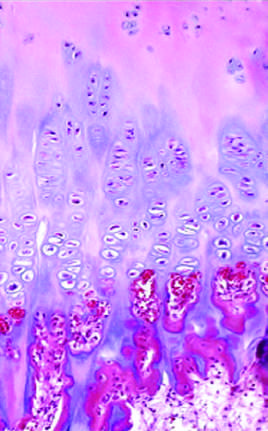what is absent?
Answer the question using a single word or phrase. The palisade of cartilage 